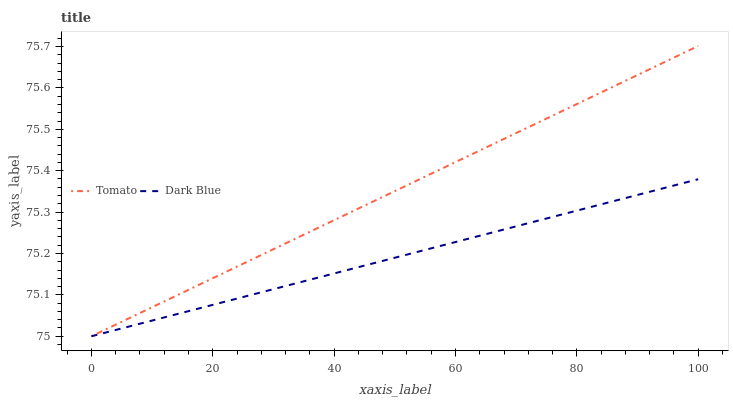Does Dark Blue have the minimum area under the curve?
Answer yes or no. Yes. Does Tomato have the maximum area under the curve?
Answer yes or no. Yes. Does Dark Blue have the maximum area under the curve?
Answer yes or no. No. Is Dark Blue the smoothest?
Answer yes or no. Yes. Is Tomato the roughest?
Answer yes or no. Yes. Is Dark Blue the roughest?
Answer yes or no. No. Does Tomato have the lowest value?
Answer yes or no. Yes. Does Tomato have the highest value?
Answer yes or no. Yes. Does Dark Blue have the highest value?
Answer yes or no. No. Does Dark Blue intersect Tomato?
Answer yes or no. Yes. Is Dark Blue less than Tomato?
Answer yes or no. No. Is Dark Blue greater than Tomato?
Answer yes or no. No. 